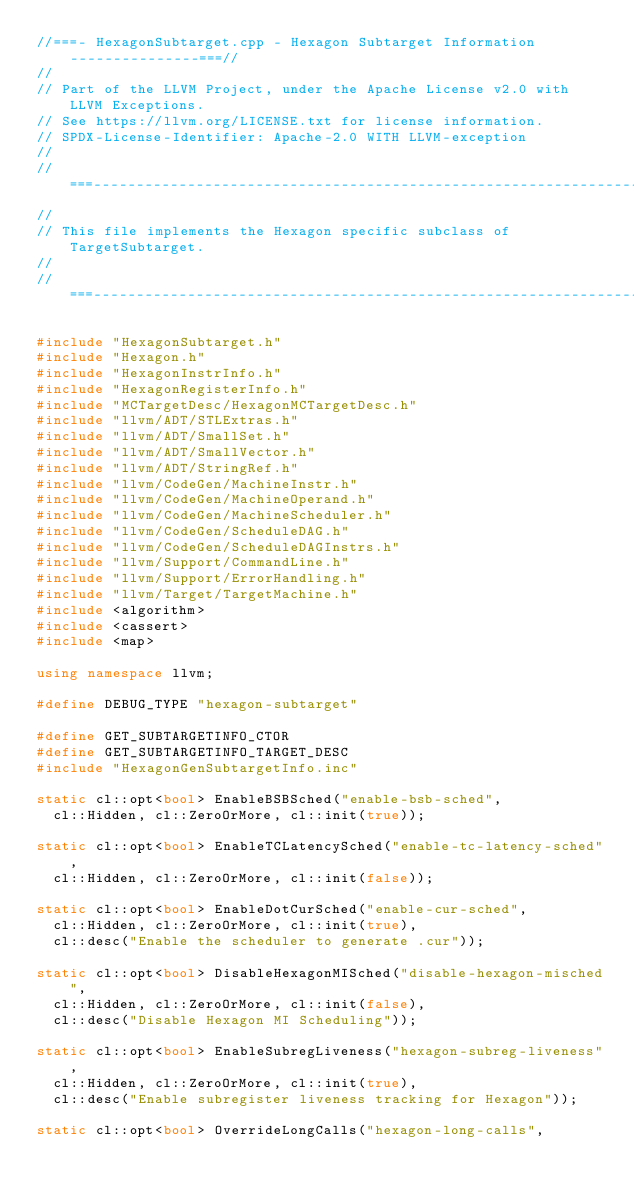Convert code to text. <code><loc_0><loc_0><loc_500><loc_500><_C++_>//===- HexagonSubtarget.cpp - Hexagon Subtarget Information ---------------===//
//
// Part of the LLVM Project, under the Apache License v2.0 with LLVM Exceptions.
// See https://llvm.org/LICENSE.txt for license information.
// SPDX-License-Identifier: Apache-2.0 WITH LLVM-exception
//
//===----------------------------------------------------------------------===//
//
// This file implements the Hexagon specific subclass of TargetSubtarget.
//
//===----------------------------------------------------------------------===//

#include "HexagonSubtarget.h"
#include "Hexagon.h"
#include "HexagonInstrInfo.h"
#include "HexagonRegisterInfo.h"
#include "MCTargetDesc/HexagonMCTargetDesc.h"
#include "llvm/ADT/STLExtras.h"
#include "llvm/ADT/SmallSet.h"
#include "llvm/ADT/SmallVector.h"
#include "llvm/ADT/StringRef.h"
#include "llvm/CodeGen/MachineInstr.h"
#include "llvm/CodeGen/MachineOperand.h"
#include "llvm/CodeGen/MachineScheduler.h"
#include "llvm/CodeGen/ScheduleDAG.h"
#include "llvm/CodeGen/ScheduleDAGInstrs.h"
#include "llvm/Support/CommandLine.h"
#include "llvm/Support/ErrorHandling.h"
#include "llvm/Target/TargetMachine.h"
#include <algorithm>
#include <cassert>
#include <map>

using namespace llvm;

#define DEBUG_TYPE "hexagon-subtarget"

#define GET_SUBTARGETINFO_CTOR
#define GET_SUBTARGETINFO_TARGET_DESC
#include "HexagonGenSubtargetInfo.inc"

static cl::opt<bool> EnableBSBSched("enable-bsb-sched",
  cl::Hidden, cl::ZeroOrMore, cl::init(true));

static cl::opt<bool> EnableTCLatencySched("enable-tc-latency-sched",
  cl::Hidden, cl::ZeroOrMore, cl::init(false));

static cl::opt<bool> EnableDotCurSched("enable-cur-sched",
  cl::Hidden, cl::ZeroOrMore, cl::init(true),
  cl::desc("Enable the scheduler to generate .cur"));

static cl::opt<bool> DisableHexagonMISched("disable-hexagon-misched",
  cl::Hidden, cl::ZeroOrMore, cl::init(false),
  cl::desc("Disable Hexagon MI Scheduling"));

static cl::opt<bool> EnableSubregLiveness("hexagon-subreg-liveness",
  cl::Hidden, cl::ZeroOrMore, cl::init(true),
  cl::desc("Enable subregister liveness tracking for Hexagon"));

static cl::opt<bool> OverrideLongCalls("hexagon-long-calls",</code> 